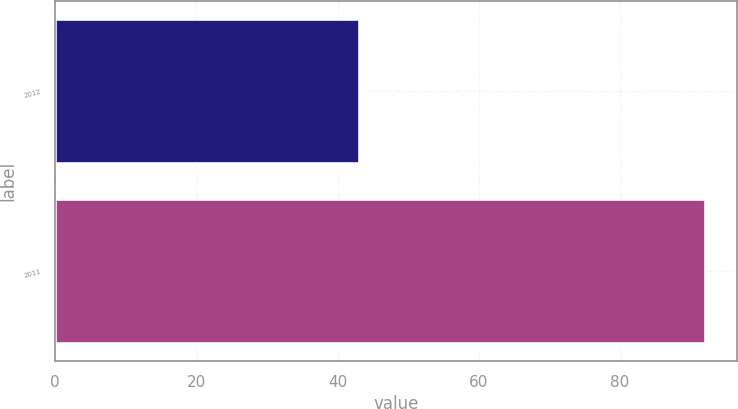<chart> <loc_0><loc_0><loc_500><loc_500><bar_chart><fcel>2012<fcel>2011<nl><fcel>43<fcel>92<nl></chart> 